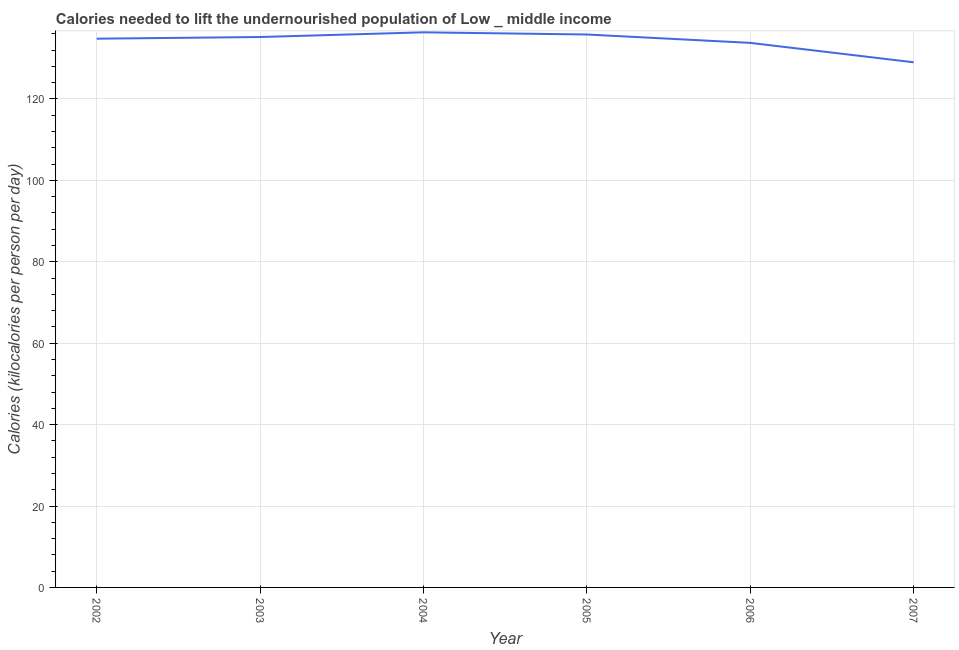What is the depth of food deficit in 2002?
Offer a very short reply. 134.81. Across all years, what is the maximum depth of food deficit?
Offer a terse response. 136.37. Across all years, what is the minimum depth of food deficit?
Keep it short and to the point. 129.01. In which year was the depth of food deficit maximum?
Give a very brief answer. 2004. In which year was the depth of food deficit minimum?
Ensure brevity in your answer.  2007. What is the sum of the depth of food deficit?
Provide a short and direct response. 805.04. What is the difference between the depth of food deficit in 2002 and 2003?
Offer a terse response. -0.41. What is the average depth of food deficit per year?
Give a very brief answer. 134.17. What is the median depth of food deficit?
Ensure brevity in your answer.  135.02. What is the ratio of the depth of food deficit in 2003 to that in 2007?
Ensure brevity in your answer.  1.05. Is the depth of food deficit in 2005 less than that in 2006?
Make the answer very short. No. Is the difference between the depth of food deficit in 2003 and 2005 greater than the difference between any two years?
Give a very brief answer. No. What is the difference between the highest and the second highest depth of food deficit?
Give a very brief answer. 0.54. What is the difference between the highest and the lowest depth of food deficit?
Keep it short and to the point. 7.36. Does the depth of food deficit monotonically increase over the years?
Ensure brevity in your answer.  No. Are the values on the major ticks of Y-axis written in scientific E-notation?
Provide a succinct answer. No. Does the graph contain any zero values?
Ensure brevity in your answer.  No. Does the graph contain grids?
Your answer should be very brief. Yes. What is the title of the graph?
Offer a very short reply. Calories needed to lift the undernourished population of Low _ middle income. What is the label or title of the X-axis?
Provide a succinct answer. Year. What is the label or title of the Y-axis?
Ensure brevity in your answer.  Calories (kilocalories per person per day). What is the Calories (kilocalories per person per day) in 2002?
Offer a terse response. 134.81. What is the Calories (kilocalories per person per day) in 2003?
Keep it short and to the point. 135.22. What is the Calories (kilocalories per person per day) in 2004?
Ensure brevity in your answer.  136.37. What is the Calories (kilocalories per person per day) in 2005?
Offer a terse response. 135.84. What is the Calories (kilocalories per person per day) of 2006?
Provide a short and direct response. 133.78. What is the Calories (kilocalories per person per day) of 2007?
Provide a short and direct response. 129.01. What is the difference between the Calories (kilocalories per person per day) in 2002 and 2003?
Keep it short and to the point. -0.41. What is the difference between the Calories (kilocalories per person per day) in 2002 and 2004?
Keep it short and to the point. -1.56. What is the difference between the Calories (kilocalories per person per day) in 2002 and 2005?
Your answer should be very brief. -1.03. What is the difference between the Calories (kilocalories per person per day) in 2002 and 2006?
Your answer should be very brief. 1.03. What is the difference between the Calories (kilocalories per person per day) in 2002 and 2007?
Your response must be concise. 5.8. What is the difference between the Calories (kilocalories per person per day) in 2003 and 2004?
Give a very brief answer. -1.15. What is the difference between the Calories (kilocalories per person per day) in 2003 and 2005?
Provide a succinct answer. -0.62. What is the difference between the Calories (kilocalories per person per day) in 2003 and 2006?
Ensure brevity in your answer.  1.44. What is the difference between the Calories (kilocalories per person per day) in 2003 and 2007?
Your answer should be compact. 6.21. What is the difference between the Calories (kilocalories per person per day) in 2004 and 2005?
Offer a very short reply. 0.54. What is the difference between the Calories (kilocalories per person per day) in 2004 and 2006?
Keep it short and to the point. 2.59. What is the difference between the Calories (kilocalories per person per day) in 2004 and 2007?
Ensure brevity in your answer.  7.36. What is the difference between the Calories (kilocalories per person per day) in 2005 and 2006?
Ensure brevity in your answer.  2.06. What is the difference between the Calories (kilocalories per person per day) in 2005 and 2007?
Keep it short and to the point. 6.83. What is the difference between the Calories (kilocalories per person per day) in 2006 and 2007?
Provide a succinct answer. 4.77. What is the ratio of the Calories (kilocalories per person per day) in 2002 to that in 2005?
Offer a terse response. 0.99. What is the ratio of the Calories (kilocalories per person per day) in 2002 to that in 2006?
Ensure brevity in your answer.  1.01. What is the ratio of the Calories (kilocalories per person per day) in 2002 to that in 2007?
Your answer should be compact. 1.04. What is the ratio of the Calories (kilocalories per person per day) in 2003 to that in 2006?
Give a very brief answer. 1.01. What is the ratio of the Calories (kilocalories per person per day) in 2003 to that in 2007?
Your answer should be compact. 1.05. What is the ratio of the Calories (kilocalories per person per day) in 2004 to that in 2007?
Provide a succinct answer. 1.06. What is the ratio of the Calories (kilocalories per person per day) in 2005 to that in 2006?
Provide a succinct answer. 1.01. What is the ratio of the Calories (kilocalories per person per day) in 2005 to that in 2007?
Keep it short and to the point. 1.05. 